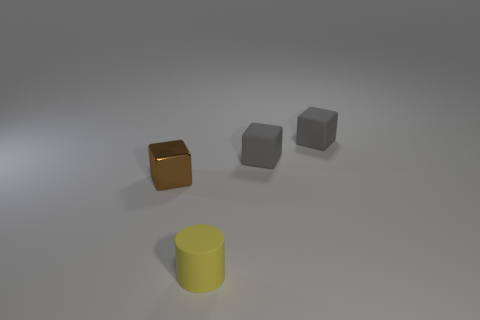Is there any other thing that is the same shape as the yellow rubber thing?
Provide a succinct answer. No. What material is the tiny thing that is in front of the thing on the left side of the object that is in front of the metal thing?
Keep it short and to the point. Rubber. Are there any yellow rubber cylinders that have the same size as the brown metallic object?
Keep it short and to the point. Yes. There is a tiny thing left of the object that is in front of the shiny thing; what color is it?
Provide a succinct answer. Brown. How many yellow things are there?
Give a very brief answer. 1. Do the small cylinder and the metal object have the same color?
Offer a terse response. No. Are there fewer gray matte things that are on the left side of the small cylinder than blocks to the right of the tiny brown cube?
Your response must be concise. Yes. The tiny cylinder is what color?
Ensure brevity in your answer.  Yellow. What number of other matte cylinders have the same color as the cylinder?
Offer a terse response. 0. There is a cylinder; are there any yellow objects in front of it?
Provide a succinct answer. No. 